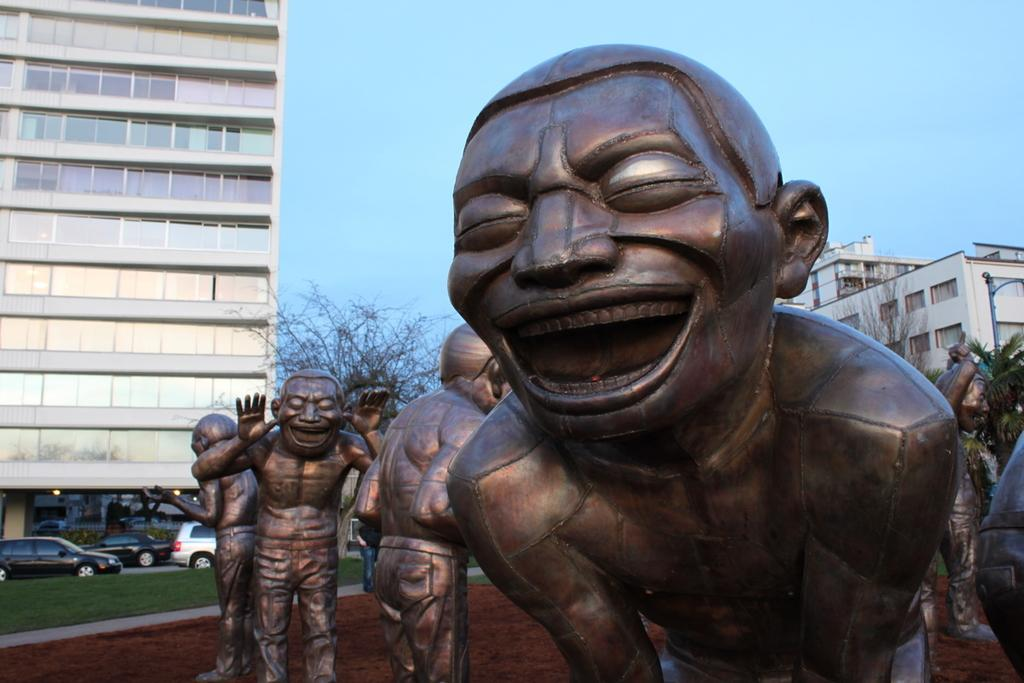What can be seen in the image besides the grass at the bottom? There are statues in the image. What can be seen in the background of the image? Cars, trees, buildings, and the sky are visible in the background of the image. What type of insect can be seen crawling on the roof of the building in the image? There is no insect visible on the roof of any building in the image. 